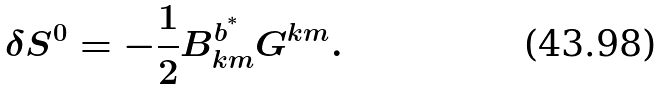Convert formula to latex. <formula><loc_0><loc_0><loc_500><loc_500>\delta S ^ { 0 } = - \frac { 1 } { 2 } B ^ { b ^ { ^ { * } } } _ { k m } G ^ { k m } .</formula> 